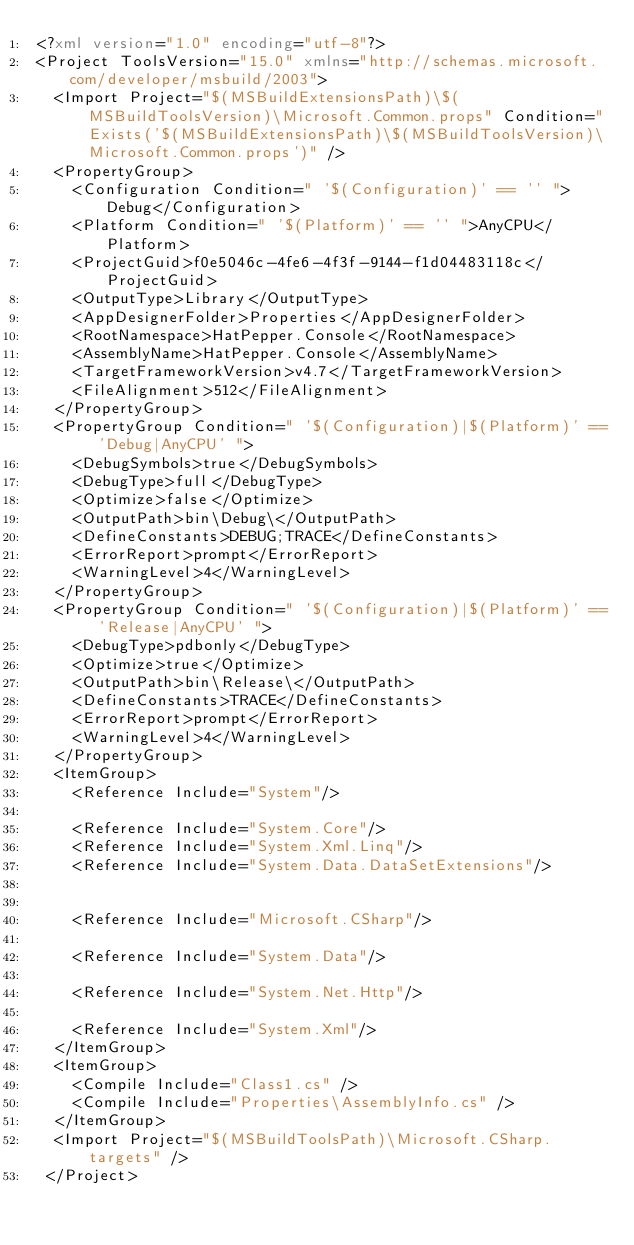Convert code to text. <code><loc_0><loc_0><loc_500><loc_500><_XML_><?xml version="1.0" encoding="utf-8"?>
<Project ToolsVersion="15.0" xmlns="http://schemas.microsoft.com/developer/msbuild/2003">
  <Import Project="$(MSBuildExtensionsPath)\$(MSBuildToolsVersion)\Microsoft.Common.props" Condition="Exists('$(MSBuildExtensionsPath)\$(MSBuildToolsVersion)\Microsoft.Common.props')" />
  <PropertyGroup>
    <Configuration Condition=" '$(Configuration)' == '' ">Debug</Configuration>
    <Platform Condition=" '$(Platform)' == '' ">AnyCPU</Platform>
    <ProjectGuid>f0e5046c-4fe6-4f3f-9144-f1d04483118c</ProjectGuid>
    <OutputType>Library</OutputType>
    <AppDesignerFolder>Properties</AppDesignerFolder>
    <RootNamespace>HatPepper.Console</RootNamespace>
    <AssemblyName>HatPepper.Console</AssemblyName>
    <TargetFrameworkVersion>v4.7</TargetFrameworkVersion>
    <FileAlignment>512</FileAlignment>
  </PropertyGroup>
  <PropertyGroup Condition=" '$(Configuration)|$(Platform)' == 'Debug|AnyCPU' ">
    <DebugSymbols>true</DebugSymbols>
    <DebugType>full</DebugType>
    <Optimize>false</Optimize>
    <OutputPath>bin\Debug\</OutputPath>
    <DefineConstants>DEBUG;TRACE</DefineConstants>
    <ErrorReport>prompt</ErrorReport>
    <WarningLevel>4</WarningLevel>
  </PropertyGroup>
  <PropertyGroup Condition=" '$(Configuration)|$(Platform)' == 'Release|AnyCPU' ">
    <DebugType>pdbonly</DebugType>
    <Optimize>true</Optimize>
    <OutputPath>bin\Release\</OutputPath>
    <DefineConstants>TRACE</DefineConstants>
    <ErrorReport>prompt</ErrorReport>
    <WarningLevel>4</WarningLevel>
  </PropertyGroup>
  <ItemGroup>
    <Reference Include="System"/>
    
    <Reference Include="System.Core"/>
    <Reference Include="System.Xml.Linq"/>
    <Reference Include="System.Data.DataSetExtensions"/>
    
    
    <Reference Include="Microsoft.CSharp"/>
    
    <Reference Include="System.Data"/>
    
    <Reference Include="System.Net.Http"/>
    
    <Reference Include="System.Xml"/>
  </ItemGroup>
  <ItemGroup>
    <Compile Include="Class1.cs" />
    <Compile Include="Properties\AssemblyInfo.cs" />
  </ItemGroup>
  <Import Project="$(MSBuildToolsPath)\Microsoft.CSharp.targets" />
 </Project>
</code> 